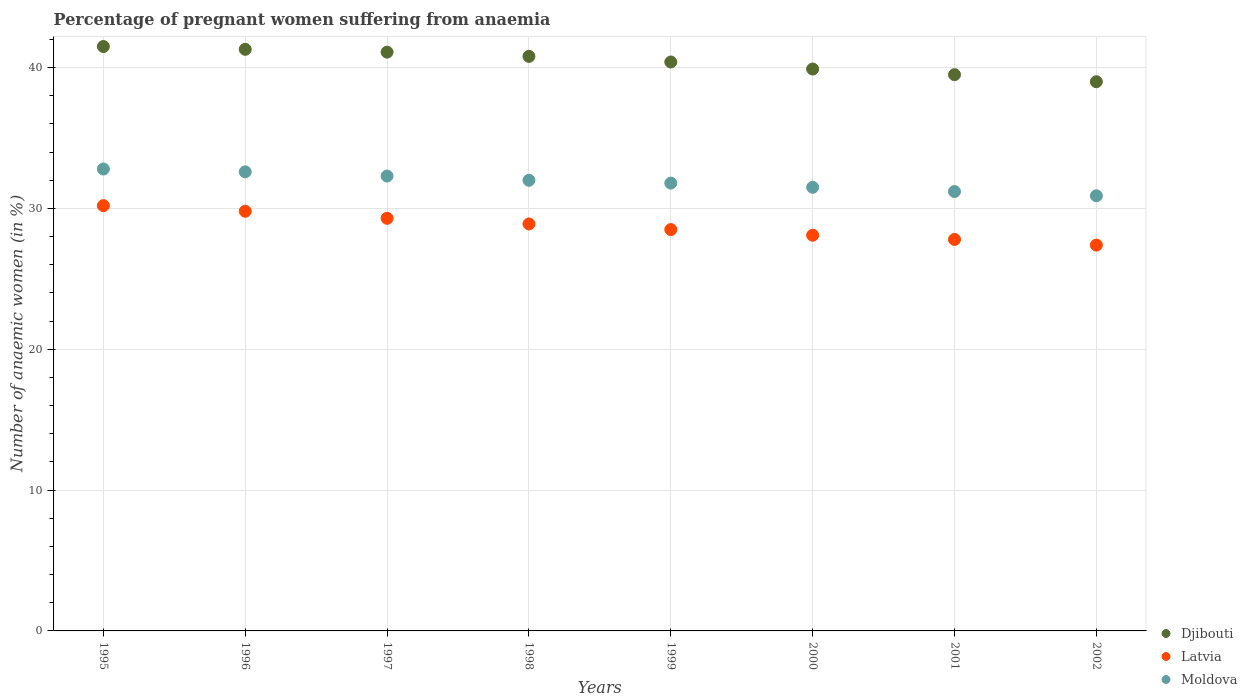How many different coloured dotlines are there?
Provide a succinct answer. 3. What is the number of anaemic women in Moldova in 2000?
Offer a very short reply. 31.5. Across all years, what is the maximum number of anaemic women in Latvia?
Offer a very short reply. 30.2. Across all years, what is the minimum number of anaemic women in Latvia?
Your response must be concise. 27.4. In which year was the number of anaemic women in Latvia minimum?
Your answer should be very brief. 2002. What is the total number of anaemic women in Moldova in the graph?
Provide a succinct answer. 255.1. What is the difference between the number of anaemic women in Djibouti in 1995 and that in 2002?
Keep it short and to the point. 2.5. What is the difference between the number of anaemic women in Latvia in 1998 and the number of anaemic women in Moldova in 1999?
Your answer should be compact. -2.9. What is the average number of anaemic women in Djibouti per year?
Provide a succinct answer. 40.44. In the year 1999, what is the difference between the number of anaemic women in Latvia and number of anaemic women in Moldova?
Offer a very short reply. -3.3. In how many years, is the number of anaemic women in Latvia greater than 34 %?
Your answer should be compact. 0. What is the ratio of the number of anaemic women in Latvia in 1996 to that in 2000?
Give a very brief answer. 1.06. Is the difference between the number of anaemic women in Latvia in 1997 and 2002 greater than the difference between the number of anaemic women in Moldova in 1997 and 2002?
Provide a short and direct response. Yes. What is the difference between the highest and the second highest number of anaemic women in Djibouti?
Make the answer very short. 0.2. What is the difference between the highest and the lowest number of anaemic women in Latvia?
Your answer should be very brief. 2.8. In how many years, is the number of anaemic women in Moldova greater than the average number of anaemic women in Moldova taken over all years?
Make the answer very short. 4. Is the sum of the number of anaemic women in Latvia in 2000 and 2002 greater than the maximum number of anaemic women in Djibouti across all years?
Provide a succinct answer. Yes. Is it the case that in every year, the sum of the number of anaemic women in Moldova and number of anaemic women in Latvia  is greater than the number of anaemic women in Djibouti?
Make the answer very short. Yes. Does the number of anaemic women in Moldova monotonically increase over the years?
Your answer should be very brief. No. Is the number of anaemic women in Moldova strictly greater than the number of anaemic women in Djibouti over the years?
Keep it short and to the point. No. Is the number of anaemic women in Moldova strictly less than the number of anaemic women in Djibouti over the years?
Make the answer very short. Yes. Does the graph contain any zero values?
Offer a terse response. No. Where does the legend appear in the graph?
Provide a short and direct response. Bottom right. How many legend labels are there?
Your answer should be very brief. 3. How are the legend labels stacked?
Offer a terse response. Vertical. What is the title of the graph?
Give a very brief answer. Percentage of pregnant women suffering from anaemia. Does "Malawi" appear as one of the legend labels in the graph?
Your answer should be compact. No. What is the label or title of the Y-axis?
Provide a succinct answer. Number of anaemic women (in %). What is the Number of anaemic women (in %) in Djibouti in 1995?
Keep it short and to the point. 41.5. What is the Number of anaemic women (in %) in Latvia in 1995?
Keep it short and to the point. 30.2. What is the Number of anaemic women (in %) in Moldova in 1995?
Ensure brevity in your answer.  32.8. What is the Number of anaemic women (in %) of Djibouti in 1996?
Your response must be concise. 41.3. What is the Number of anaemic women (in %) of Latvia in 1996?
Your answer should be compact. 29.8. What is the Number of anaemic women (in %) in Moldova in 1996?
Your answer should be compact. 32.6. What is the Number of anaemic women (in %) in Djibouti in 1997?
Make the answer very short. 41.1. What is the Number of anaemic women (in %) of Latvia in 1997?
Ensure brevity in your answer.  29.3. What is the Number of anaemic women (in %) in Moldova in 1997?
Your answer should be compact. 32.3. What is the Number of anaemic women (in %) of Djibouti in 1998?
Offer a terse response. 40.8. What is the Number of anaemic women (in %) of Latvia in 1998?
Your response must be concise. 28.9. What is the Number of anaemic women (in %) of Moldova in 1998?
Give a very brief answer. 32. What is the Number of anaemic women (in %) of Djibouti in 1999?
Provide a short and direct response. 40.4. What is the Number of anaemic women (in %) in Latvia in 1999?
Your answer should be very brief. 28.5. What is the Number of anaemic women (in %) of Moldova in 1999?
Your answer should be compact. 31.8. What is the Number of anaemic women (in %) of Djibouti in 2000?
Your answer should be compact. 39.9. What is the Number of anaemic women (in %) of Latvia in 2000?
Offer a very short reply. 28.1. What is the Number of anaemic women (in %) of Moldova in 2000?
Offer a very short reply. 31.5. What is the Number of anaemic women (in %) in Djibouti in 2001?
Offer a terse response. 39.5. What is the Number of anaemic women (in %) of Latvia in 2001?
Your response must be concise. 27.8. What is the Number of anaemic women (in %) of Moldova in 2001?
Provide a succinct answer. 31.2. What is the Number of anaemic women (in %) in Djibouti in 2002?
Make the answer very short. 39. What is the Number of anaemic women (in %) of Latvia in 2002?
Offer a terse response. 27.4. What is the Number of anaemic women (in %) in Moldova in 2002?
Your answer should be very brief. 30.9. Across all years, what is the maximum Number of anaemic women (in %) of Djibouti?
Offer a terse response. 41.5. Across all years, what is the maximum Number of anaemic women (in %) in Latvia?
Your answer should be very brief. 30.2. Across all years, what is the maximum Number of anaemic women (in %) of Moldova?
Provide a succinct answer. 32.8. Across all years, what is the minimum Number of anaemic women (in %) of Djibouti?
Provide a short and direct response. 39. Across all years, what is the minimum Number of anaemic women (in %) in Latvia?
Make the answer very short. 27.4. Across all years, what is the minimum Number of anaemic women (in %) of Moldova?
Make the answer very short. 30.9. What is the total Number of anaemic women (in %) in Djibouti in the graph?
Provide a short and direct response. 323.5. What is the total Number of anaemic women (in %) in Latvia in the graph?
Your answer should be very brief. 230. What is the total Number of anaemic women (in %) in Moldova in the graph?
Offer a terse response. 255.1. What is the difference between the Number of anaemic women (in %) in Moldova in 1995 and that in 1996?
Keep it short and to the point. 0.2. What is the difference between the Number of anaemic women (in %) of Moldova in 1995 and that in 1998?
Provide a succinct answer. 0.8. What is the difference between the Number of anaemic women (in %) of Djibouti in 1995 and that in 1999?
Your answer should be compact. 1.1. What is the difference between the Number of anaemic women (in %) of Moldova in 1995 and that in 1999?
Make the answer very short. 1. What is the difference between the Number of anaemic women (in %) of Djibouti in 1995 and that in 2000?
Provide a succinct answer. 1.6. What is the difference between the Number of anaemic women (in %) in Latvia in 1995 and that in 2000?
Ensure brevity in your answer.  2.1. What is the difference between the Number of anaemic women (in %) of Djibouti in 1995 and that in 2001?
Your response must be concise. 2. What is the difference between the Number of anaemic women (in %) in Latvia in 1995 and that in 2001?
Give a very brief answer. 2.4. What is the difference between the Number of anaemic women (in %) of Moldova in 1995 and that in 2001?
Provide a succinct answer. 1.6. What is the difference between the Number of anaemic women (in %) in Djibouti in 1995 and that in 2002?
Offer a very short reply. 2.5. What is the difference between the Number of anaemic women (in %) of Djibouti in 1996 and that in 1997?
Provide a succinct answer. 0.2. What is the difference between the Number of anaemic women (in %) of Latvia in 1996 and that in 1998?
Offer a very short reply. 0.9. What is the difference between the Number of anaemic women (in %) in Moldova in 1996 and that in 1998?
Give a very brief answer. 0.6. What is the difference between the Number of anaemic women (in %) of Djibouti in 1996 and that in 2000?
Make the answer very short. 1.4. What is the difference between the Number of anaemic women (in %) in Latvia in 1996 and that in 2000?
Provide a short and direct response. 1.7. What is the difference between the Number of anaemic women (in %) in Djibouti in 1996 and that in 2001?
Provide a short and direct response. 1.8. What is the difference between the Number of anaemic women (in %) of Moldova in 1996 and that in 2001?
Your answer should be very brief. 1.4. What is the difference between the Number of anaemic women (in %) in Djibouti in 1996 and that in 2002?
Provide a succinct answer. 2.3. What is the difference between the Number of anaemic women (in %) in Latvia in 1996 and that in 2002?
Offer a very short reply. 2.4. What is the difference between the Number of anaemic women (in %) in Moldova in 1996 and that in 2002?
Keep it short and to the point. 1.7. What is the difference between the Number of anaemic women (in %) in Djibouti in 1997 and that in 1998?
Provide a succinct answer. 0.3. What is the difference between the Number of anaemic women (in %) in Latvia in 1997 and that in 1998?
Make the answer very short. 0.4. What is the difference between the Number of anaemic women (in %) of Latvia in 1997 and that in 1999?
Your response must be concise. 0.8. What is the difference between the Number of anaemic women (in %) in Moldova in 1997 and that in 1999?
Your answer should be very brief. 0.5. What is the difference between the Number of anaemic women (in %) in Latvia in 1997 and that in 2001?
Keep it short and to the point. 1.5. What is the difference between the Number of anaemic women (in %) of Djibouti in 1997 and that in 2002?
Your answer should be very brief. 2.1. What is the difference between the Number of anaemic women (in %) of Moldova in 1997 and that in 2002?
Provide a succinct answer. 1.4. What is the difference between the Number of anaemic women (in %) in Djibouti in 1998 and that in 1999?
Your response must be concise. 0.4. What is the difference between the Number of anaemic women (in %) in Moldova in 1998 and that in 1999?
Provide a succinct answer. 0.2. What is the difference between the Number of anaemic women (in %) of Djibouti in 1998 and that in 2000?
Make the answer very short. 0.9. What is the difference between the Number of anaemic women (in %) in Moldova in 1998 and that in 2000?
Give a very brief answer. 0.5. What is the difference between the Number of anaemic women (in %) of Moldova in 1998 and that in 2002?
Keep it short and to the point. 1.1. What is the difference between the Number of anaemic women (in %) of Djibouti in 1999 and that in 2000?
Provide a succinct answer. 0.5. What is the difference between the Number of anaemic women (in %) of Latvia in 1999 and that in 2000?
Your answer should be very brief. 0.4. What is the difference between the Number of anaemic women (in %) of Moldova in 1999 and that in 2000?
Make the answer very short. 0.3. What is the difference between the Number of anaemic women (in %) of Latvia in 1999 and that in 2001?
Keep it short and to the point. 0.7. What is the difference between the Number of anaemic women (in %) of Djibouti in 1999 and that in 2002?
Ensure brevity in your answer.  1.4. What is the difference between the Number of anaemic women (in %) of Moldova in 1999 and that in 2002?
Provide a succinct answer. 0.9. What is the difference between the Number of anaemic women (in %) of Djibouti in 2000 and that in 2002?
Your answer should be compact. 0.9. What is the difference between the Number of anaemic women (in %) in Latvia in 2000 and that in 2002?
Make the answer very short. 0.7. What is the difference between the Number of anaemic women (in %) in Moldova in 2000 and that in 2002?
Keep it short and to the point. 0.6. What is the difference between the Number of anaemic women (in %) in Djibouti in 2001 and that in 2002?
Offer a very short reply. 0.5. What is the difference between the Number of anaemic women (in %) in Moldova in 2001 and that in 2002?
Give a very brief answer. 0.3. What is the difference between the Number of anaemic women (in %) of Djibouti in 1995 and the Number of anaemic women (in %) of Moldova in 1996?
Your answer should be compact. 8.9. What is the difference between the Number of anaemic women (in %) of Latvia in 1995 and the Number of anaemic women (in %) of Moldova in 1996?
Keep it short and to the point. -2.4. What is the difference between the Number of anaemic women (in %) in Djibouti in 1995 and the Number of anaemic women (in %) in Latvia in 1997?
Make the answer very short. 12.2. What is the difference between the Number of anaemic women (in %) of Djibouti in 1995 and the Number of anaemic women (in %) of Moldova in 1997?
Give a very brief answer. 9.2. What is the difference between the Number of anaemic women (in %) of Latvia in 1995 and the Number of anaemic women (in %) of Moldova in 1997?
Give a very brief answer. -2.1. What is the difference between the Number of anaemic women (in %) of Djibouti in 1995 and the Number of anaemic women (in %) of Moldova in 1999?
Offer a very short reply. 9.7. What is the difference between the Number of anaemic women (in %) in Djibouti in 1995 and the Number of anaemic women (in %) in Latvia in 2001?
Provide a succinct answer. 13.7. What is the difference between the Number of anaemic women (in %) in Djibouti in 1995 and the Number of anaemic women (in %) in Moldova in 2002?
Your response must be concise. 10.6. What is the difference between the Number of anaemic women (in %) of Latvia in 1995 and the Number of anaemic women (in %) of Moldova in 2002?
Offer a terse response. -0.7. What is the difference between the Number of anaemic women (in %) of Djibouti in 1996 and the Number of anaemic women (in %) of Latvia in 1997?
Give a very brief answer. 12. What is the difference between the Number of anaemic women (in %) of Djibouti in 1996 and the Number of anaemic women (in %) of Moldova in 1997?
Provide a succinct answer. 9. What is the difference between the Number of anaemic women (in %) of Djibouti in 1996 and the Number of anaemic women (in %) of Latvia in 1998?
Offer a terse response. 12.4. What is the difference between the Number of anaemic women (in %) in Latvia in 1996 and the Number of anaemic women (in %) in Moldova in 1999?
Offer a very short reply. -2. What is the difference between the Number of anaemic women (in %) of Latvia in 1996 and the Number of anaemic women (in %) of Moldova in 2000?
Keep it short and to the point. -1.7. What is the difference between the Number of anaemic women (in %) of Djibouti in 1996 and the Number of anaemic women (in %) of Latvia in 2001?
Your response must be concise. 13.5. What is the difference between the Number of anaemic women (in %) in Djibouti in 1996 and the Number of anaemic women (in %) in Latvia in 2002?
Make the answer very short. 13.9. What is the difference between the Number of anaemic women (in %) of Djibouti in 1997 and the Number of anaemic women (in %) of Latvia in 1998?
Ensure brevity in your answer.  12.2. What is the difference between the Number of anaemic women (in %) in Latvia in 1997 and the Number of anaemic women (in %) in Moldova in 1998?
Your response must be concise. -2.7. What is the difference between the Number of anaemic women (in %) of Djibouti in 1997 and the Number of anaemic women (in %) of Moldova in 1999?
Your answer should be very brief. 9.3. What is the difference between the Number of anaemic women (in %) of Latvia in 1997 and the Number of anaemic women (in %) of Moldova in 1999?
Ensure brevity in your answer.  -2.5. What is the difference between the Number of anaemic women (in %) in Djibouti in 1997 and the Number of anaemic women (in %) in Latvia in 2000?
Give a very brief answer. 13. What is the difference between the Number of anaemic women (in %) in Djibouti in 1997 and the Number of anaemic women (in %) in Moldova in 2000?
Make the answer very short. 9.6. What is the difference between the Number of anaemic women (in %) of Latvia in 1997 and the Number of anaemic women (in %) of Moldova in 2000?
Ensure brevity in your answer.  -2.2. What is the difference between the Number of anaemic women (in %) in Latvia in 1997 and the Number of anaemic women (in %) in Moldova in 2002?
Your response must be concise. -1.6. What is the difference between the Number of anaemic women (in %) of Djibouti in 1998 and the Number of anaemic women (in %) of Latvia in 2000?
Offer a very short reply. 12.7. What is the difference between the Number of anaemic women (in %) of Djibouti in 1998 and the Number of anaemic women (in %) of Latvia in 2001?
Offer a very short reply. 13. What is the difference between the Number of anaemic women (in %) in Djibouti in 1998 and the Number of anaemic women (in %) in Moldova in 2001?
Your answer should be compact. 9.6. What is the difference between the Number of anaemic women (in %) of Djibouti in 1999 and the Number of anaemic women (in %) of Latvia in 2000?
Give a very brief answer. 12.3. What is the difference between the Number of anaemic women (in %) of Djibouti in 1999 and the Number of anaemic women (in %) of Moldova in 2000?
Your answer should be very brief. 8.9. What is the difference between the Number of anaemic women (in %) of Latvia in 1999 and the Number of anaemic women (in %) of Moldova in 2000?
Give a very brief answer. -3. What is the difference between the Number of anaemic women (in %) of Latvia in 1999 and the Number of anaemic women (in %) of Moldova in 2001?
Your answer should be very brief. -2.7. What is the difference between the Number of anaemic women (in %) of Djibouti in 1999 and the Number of anaemic women (in %) of Latvia in 2002?
Make the answer very short. 13. What is the difference between the Number of anaemic women (in %) in Djibouti in 1999 and the Number of anaemic women (in %) in Moldova in 2002?
Your response must be concise. 9.5. What is the difference between the Number of anaemic women (in %) in Latvia in 1999 and the Number of anaemic women (in %) in Moldova in 2002?
Provide a succinct answer. -2.4. What is the difference between the Number of anaemic women (in %) in Latvia in 2000 and the Number of anaemic women (in %) in Moldova in 2001?
Your response must be concise. -3.1. What is the difference between the Number of anaemic women (in %) in Djibouti in 2000 and the Number of anaemic women (in %) in Latvia in 2002?
Provide a short and direct response. 12.5. What is the difference between the Number of anaemic women (in %) of Djibouti in 2000 and the Number of anaemic women (in %) of Moldova in 2002?
Offer a very short reply. 9. What is the average Number of anaemic women (in %) in Djibouti per year?
Keep it short and to the point. 40.44. What is the average Number of anaemic women (in %) of Latvia per year?
Your answer should be very brief. 28.75. What is the average Number of anaemic women (in %) of Moldova per year?
Provide a succinct answer. 31.89. In the year 1995, what is the difference between the Number of anaemic women (in %) of Djibouti and Number of anaemic women (in %) of Moldova?
Offer a terse response. 8.7. In the year 1997, what is the difference between the Number of anaemic women (in %) in Djibouti and Number of anaemic women (in %) in Latvia?
Your response must be concise. 11.8. In the year 1998, what is the difference between the Number of anaemic women (in %) of Djibouti and Number of anaemic women (in %) of Latvia?
Keep it short and to the point. 11.9. In the year 1998, what is the difference between the Number of anaemic women (in %) in Djibouti and Number of anaemic women (in %) in Moldova?
Give a very brief answer. 8.8. In the year 1998, what is the difference between the Number of anaemic women (in %) in Latvia and Number of anaemic women (in %) in Moldova?
Give a very brief answer. -3.1. In the year 1999, what is the difference between the Number of anaemic women (in %) in Djibouti and Number of anaemic women (in %) in Latvia?
Provide a succinct answer. 11.9. In the year 1999, what is the difference between the Number of anaemic women (in %) of Latvia and Number of anaemic women (in %) of Moldova?
Offer a terse response. -3.3. In the year 2000, what is the difference between the Number of anaemic women (in %) of Djibouti and Number of anaemic women (in %) of Latvia?
Keep it short and to the point. 11.8. In the year 2001, what is the difference between the Number of anaemic women (in %) of Djibouti and Number of anaemic women (in %) of Latvia?
Offer a terse response. 11.7. In the year 2002, what is the difference between the Number of anaemic women (in %) in Djibouti and Number of anaemic women (in %) in Latvia?
Make the answer very short. 11.6. In the year 2002, what is the difference between the Number of anaemic women (in %) in Djibouti and Number of anaemic women (in %) in Moldova?
Ensure brevity in your answer.  8.1. In the year 2002, what is the difference between the Number of anaemic women (in %) in Latvia and Number of anaemic women (in %) in Moldova?
Make the answer very short. -3.5. What is the ratio of the Number of anaemic women (in %) in Djibouti in 1995 to that in 1996?
Offer a terse response. 1. What is the ratio of the Number of anaemic women (in %) of Latvia in 1995 to that in 1996?
Offer a very short reply. 1.01. What is the ratio of the Number of anaemic women (in %) in Moldova in 1995 to that in 1996?
Keep it short and to the point. 1.01. What is the ratio of the Number of anaemic women (in %) in Djibouti in 1995 to that in 1997?
Your answer should be very brief. 1.01. What is the ratio of the Number of anaemic women (in %) in Latvia in 1995 to that in 1997?
Make the answer very short. 1.03. What is the ratio of the Number of anaemic women (in %) in Moldova in 1995 to that in 1997?
Your answer should be compact. 1.02. What is the ratio of the Number of anaemic women (in %) of Djibouti in 1995 to that in 1998?
Ensure brevity in your answer.  1.02. What is the ratio of the Number of anaemic women (in %) in Latvia in 1995 to that in 1998?
Provide a short and direct response. 1.04. What is the ratio of the Number of anaemic women (in %) of Djibouti in 1995 to that in 1999?
Give a very brief answer. 1.03. What is the ratio of the Number of anaemic women (in %) in Latvia in 1995 to that in 1999?
Your response must be concise. 1.06. What is the ratio of the Number of anaemic women (in %) in Moldova in 1995 to that in 1999?
Your response must be concise. 1.03. What is the ratio of the Number of anaemic women (in %) of Djibouti in 1995 to that in 2000?
Keep it short and to the point. 1.04. What is the ratio of the Number of anaemic women (in %) of Latvia in 1995 to that in 2000?
Ensure brevity in your answer.  1.07. What is the ratio of the Number of anaemic women (in %) of Moldova in 1995 to that in 2000?
Offer a very short reply. 1.04. What is the ratio of the Number of anaemic women (in %) of Djibouti in 1995 to that in 2001?
Your answer should be very brief. 1.05. What is the ratio of the Number of anaemic women (in %) of Latvia in 1995 to that in 2001?
Your response must be concise. 1.09. What is the ratio of the Number of anaemic women (in %) in Moldova in 1995 to that in 2001?
Offer a terse response. 1.05. What is the ratio of the Number of anaemic women (in %) of Djibouti in 1995 to that in 2002?
Give a very brief answer. 1.06. What is the ratio of the Number of anaemic women (in %) of Latvia in 1995 to that in 2002?
Make the answer very short. 1.1. What is the ratio of the Number of anaemic women (in %) in Moldova in 1995 to that in 2002?
Ensure brevity in your answer.  1.06. What is the ratio of the Number of anaemic women (in %) in Latvia in 1996 to that in 1997?
Keep it short and to the point. 1.02. What is the ratio of the Number of anaemic women (in %) in Moldova in 1996 to that in 1997?
Keep it short and to the point. 1.01. What is the ratio of the Number of anaemic women (in %) in Djibouti in 1996 to that in 1998?
Your response must be concise. 1.01. What is the ratio of the Number of anaemic women (in %) in Latvia in 1996 to that in 1998?
Give a very brief answer. 1.03. What is the ratio of the Number of anaemic women (in %) of Moldova in 1996 to that in 1998?
Your answer should be compact. 1.02. What is the ratio of the Number of anaemic women (in %) of Djibouti in 1996 to that in 1999?
Your answer should be compact. 1.02. What is the ratio of the Number of anaemic women (in %) of Latvia in 1996 to that in 1999?
Give a very brief answer. 1.05. What is the ratio of the Number of anaemic women (in %) of Moldova in 1996 to that in 1999?
Ensure brevity in your answer.  1.03. What is the ratio of the Number of anaemic women (in %) in Djibouti in 1996 to that in 2000?
Your response must be concise. 1.04. What is the ratio of the Number of anaemic women (in %) of Latvia in 1996 to that in 2000?
Give a very brief answer. 1.06. What is the ratio of the Number of anaemic women (in %) in Moldova in 1996 to that in 2000?
Give a very brief answer. 1.03. What is the ratio of the Number of anaemic women (in %) in Djibouti in 1996 to that in 2001?
Your response must be concise. 1.05. What is the ratio of the Number of anaemic women (in %) in Latvia in 1996 to that in 2001?
Offer a terse response. 1.07. What is the ratio of the Number of anaemic women (in %) of Moldova in 1996 to that in 2001?
Offer a terse response. 1.04. What is the ratio of the Number of anaemic women (in %) in Djibouti in 1996 to that in 2002?
Keep it short and to the point. 1.06. What is the ratio of the Number of anaemic women (in %) in Latvia in 1996 to that in 2002?
Ensure brevity in your answer.  1.09. What is the ratio of the Number of anaemic women (in %) in Moldova in 1996 to that in 2002?
Your answer should be compact. 1.05. What is the ratio of the Number of anaemic women (in %) of Djibouti in 1997 to that in 1998?
Offer a terse response. 1.01. What is the ratio of the Number of anaemic women (in %) in Latvia in 1997 to that in 1998?
Provide a succinct answer. 1.01. What is the ratio of the Number of anaemic women (in %) of Moldova in 1997 to that in 1998?
Provide a succinct answer. 1.01. What is the ratio of the Number of anaemic women (in %) in Djibouti in 1997 to that in 1999?
Your answer should be very brief. 1.02. What is the ratio of the Number of anaemic women (in %) in Latvia in 1997 to that in 1999?
Offer a very short reply. 1.03. What is the ratio of the Number of anaemic women (in %) of Moldova in 1997 to that in 1999?
Keep it short and to the point. 1.02. What is the ratio of the Number of anaemic women (in %) in Djibouti in 1997 to that in 2000?
Offer a very short reply. 1.03. What is the ratio of the Number of anaemic women (in %) in Latvia in 1997 to that in 2000?
Your answer should be very brief. 1.04. What is the ratio of the Number of anaemic women (in %) of Moldova in 1997 to that in 2000?
Keep it short and to the point. 1.03. What is the ratio of the Number of anaemic women (in %) of Djibouti in 1997 to that in 2001?
Offer a terse response. 1.04. What is the ratio of the Number of anaemic women (in %) in Latvia in 1997 to that in 2001?
Your answer should be compact. 1.05. What is the ratio of the Number of anaemic women (in %) in Moldova in 1997 to that in 2001?
Keep it short and to the point. 1.04. What is the ratio of the Number of anaemic women (in %) in Djibouti in 1997 to that in 2002?
Your answer should be compact. 1.05. What is the ratio of the Number of anaemic women (in %) in Latvia in 1997 to that in 2002?
Offer a terse response. 1.07. What is the ratio of the Number of anaemic women (in %) of Moldova in 1997 to that in 2002?
Your response must be concise. 1.05. What is the ratio of the Number of anaemic women (in %) of Djibouti in 1998 to that in 1999?
Make the answer very short. 1.01. What is the ratio of the Number of anaemic women (in %) in Latvia in 1998 to that in 1999?
Offer a terse response. 1.01. What is the ratio of the Number of anaemic women (in %) in Moldova in 1998 to that in 1999?
Give a very brief answer. 1.01. What is the ratio of the Number of anaemic women (in %) in Djibouti in 1998 to that in 2000?
Make the answer very short. 1.02. What is the ratio of the Number of anaemic women (in %) of Latvia in 1998 to that in 2000?
Your response must be concise. 1.03. What is the ratio of the Number of anaemic women (in %) in Moldova in 1998 to that in 2000?
Offer a terse response. 1.02. What is the ratio of the Number of anaemic women (in %) of Djibouti in 1998 to that in 2001?
Provide a short and direct response. 1.03. What is the ratio of the Number of anaemic women (in %) of Latvia in 1998 to that in 2001?
Keep it short and to the point. 1.04. What is the ratio of the Number of anaemic women (in %) of Moldova in 1998 to that in 2001?
Your response must be concise. 1.03. What is the ratio of the Number of anaemic women (in %) in Djibouti in 1998 to that in 2002?
Ensure brevity in your answer.  1.05. What is the ratio of the Number of anaemic women (in %) in Latvia in 1998 to that in 2002?
Your response must be concise. 1.05. What is the ratio of the Number of anaemic women (in %) in Moldova in 1998 to that in 2002?
Make the answer very short. 1.04. What is the ratio of the Number of anaemic women (in %) in Djibouti in 1999 to that in 2000?
Offer a terse response. 1.01. What is the ratio of the Number of anaemic women (in %) of Latvia in 1999 to that in 2000?
Give a very brief answer. 1.01. What is the ratio of the Number of anaemic women (in %) of Moldova in 1999 to that in 2000?
Ensure brevity in your answer.  1.01. What is the ratio of the Number of anaemic women (in %) in Djibouti in 1999 to that in 2001?
Offer a very short reply. 1.02. What is the ratio of the Number of anaemic women (in %) in Latvia in 1999 to that in 2001?
Provide a succinct answer. 1.03. What is the ratio of the Number of anaemic women (in %) of Moldova in 1999 to that in 2001?
Ensure brevity in your answer.  1.02. What is the ratio of the Number of anaemic women (in %) of Djibouti in 1999 to that in 2002?
Offer a very short reply. 1.04. What is the ratio of the Number of anaemic women (in %) in Latvia in 1999 to that in 2002?
Your answer should be compact. 1.04. What is the ratio of the Number of anaemic women (in %) of Moldova in 1999 to that in 2002?
Your answer should be very brief. 1.03. What is the ratio of the Number of anaemic women (in %) in Djibouti in 2000 to that in 2001?
Offer a terse response. 1.01. What is the ratio of the Number of anaemic women (in %) in Latvia in 2000 to that in 2001?
Give a very brief answer. 1.01. What is the ratio of the Number of anaemic women (in %) in Moldova in 2000 to that in 2001?
Your response must be concise. 1.01. What is the ratio of the Number of anaemic women (in %) of Djibouti in 2000 to that in 2002?
Your answer should be compact. 1.02. What is the ratio of the Number of anaemic women (in %) in Latvia in 2000 to that in 2002?
Make the answer very short. 1.03. What is the ratio of the Number of anaemic women (in %) of Moldova in 2000 to that in 2002?
Provide a succinct answer. 1.02. What is the ratio of the Number of anaemic women (in %) of Djibouti in 2001 to that in 2002?
Offer a terse response. 1.01. What is the ratio of the Number of anaemic women (in %) of Latvia in 2001 to that in 2002?
Ensure brevity in your answer.  1.01. What is the ratio of the Number of anaemic women (in %) in Moldova in 2001 to that in 2002?
Offer a very short reply. 1.01. What is the difference between the highest and the second highest Number of anaemic women (in %) of Djibouti?
Provide a succinct answer. 0.2. 